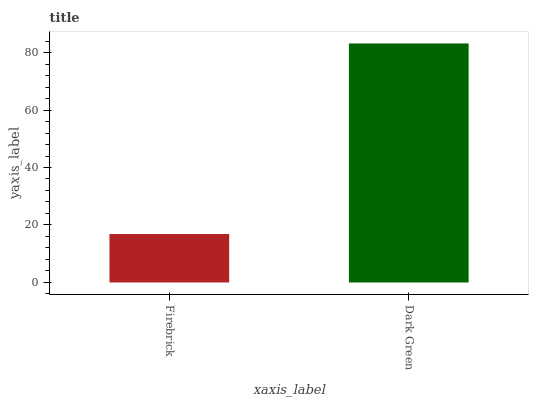Is Dark Green the minimum?
Answer yes or no. No. Is Dark Green greater than Firebrick?
Answer yes or no. Yes. Is Firebrick less than Dark Green?
Answer yes or no. Yes. Is Firebrick greater than Dark Green?
Answer yes or no. No. Is Dark Green less than Firebrick?
Answer yes or no. No. Is Dark Green the high median?
Answer yes or no. Yes. Is Firebrick the low median?
Answer yes or no. Yes. Is Firebrick the high median?
Answer yes or no. No. Is Dark Green the low median?
Answer yes or no. No. 